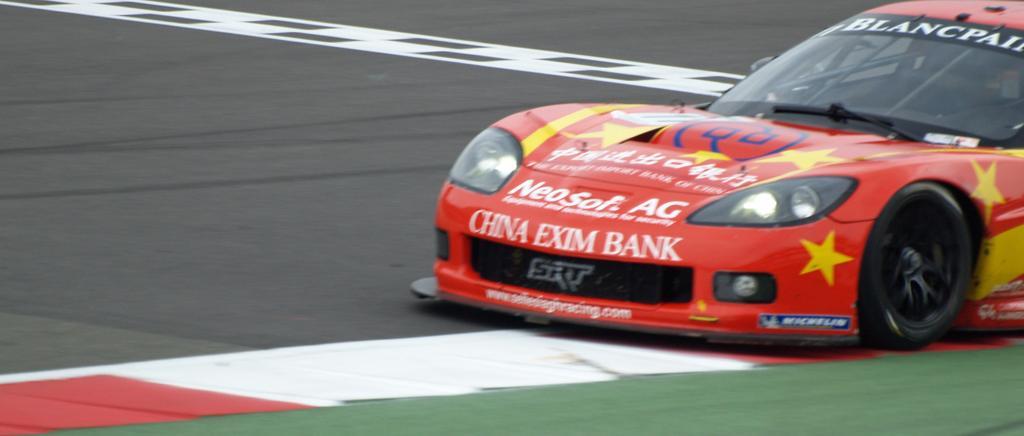What is the main subject in the foreground of the image? There is a car in the foreground of the image. What is visible at the bottom of the image? There is a road at the bottom of the image. Can you see any caves or sand in the image? No, there are no caves or sand visible in the image. What is the relation between the car and the road in the image? The car is on the road in the image, indicating that the car is likely being driven or parked on the road. 